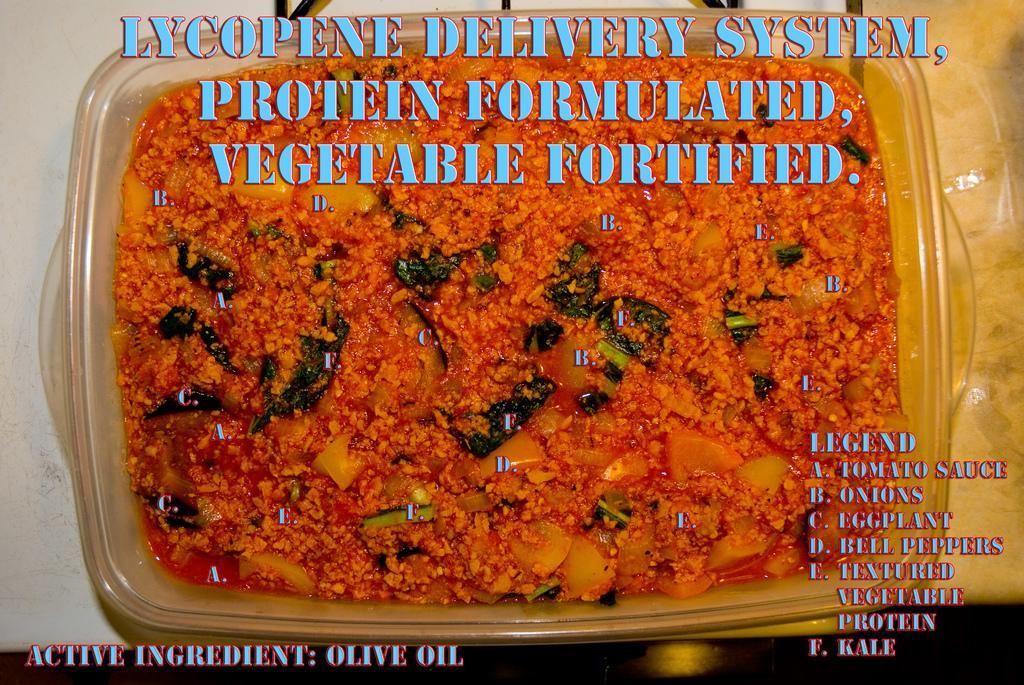Can you describe this image briefly? In this image we can see a plastic box containing food placed on the table and there is text. 